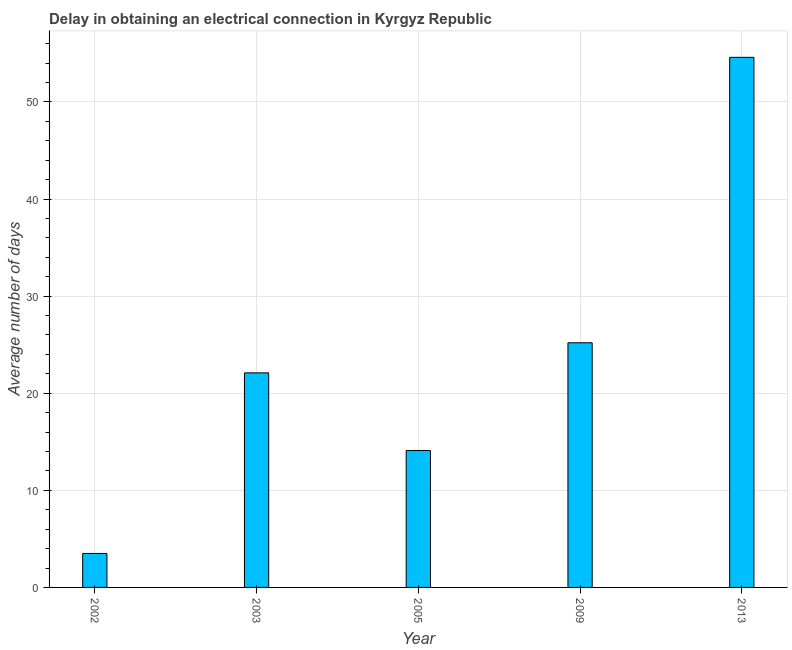What is the title of the graph?
Provide a short and direct response. Delay in obtaining an electrical connection in Kyrgyz Republic. What is the label or title of the Y-axis?
Give a very brief answer. Average number of days. What is the dalay in electrical connection in 2005?
Provide a short and direct response. 14.1. Across all years, what is the maximum dalay in electrical connection?
Provide a short and direct response. 54.6. Across all years, what is the minimum dalay in electrical connection?
Give a very brief answer. 3.5. In which year was the dalay in electrical connection maximum?
Your answer should be compact. 2013. What is the sum of the dalay in electrical connection?
Offer a terse response. 119.5. What is the difference between the dalay in electrical connection in 2002 and 2003?
Keep it short and to the point. -18.6. What is the average dalay in electrical connection per year?
Provide a succinct answer. 23.9. What is the median dalay in electrical connection?
Your answer should be compact. 22.1. In how many years, is the dalay in electrical connection greater than 54 days?
Keep it short and to the point. 1. What is the ratio of the dalay in electrical connection in 2009 to that in 2013?
Your answer should be compact. 0.46. Is the dalay in electrical connection in 2003 less than that in 2005?
Make the answer very short. No. Is the difference between the dalay in electrical connection in 2002 and 2009 greater than the difference between any two years?
Provide a succinct answer. No. What is the difference between the highest and the second highest dalay in electrical connection?
Your response must be concise. 29.4. What is the difference between the highest and the lowest dalay in electrical connection?
Your response must be concise. 51.1. Are all the bars in the graph horizontal?
Give a very brief answer. No. What is the difference between two consecutive major ticks on the Y-axis?
Provide a short and direct response. 10. Are the values on the major ticks of Y-axis written in scientific E-notation?
Make the answer very short. No. What is the Average number of days of 2002?
Ensure brevity in your answer.  3.5. What is the Average number of days in 2003?
Make the answer very short. 22.1. What is the Average number of days of 2009?
Your answer should be very brief. 25.2. What is the Average number of days in 2013?
Provide a succinct answer. 54.6. What is the difference between the Average number of days in 2002 and 2003?
Ensure brevity in your answer.  -18.6. What is the difference between the Average number of days in 2002 and 2009?
Provide a succinct answer. -21.7. What is the difference between the Average number of days in 2002 and 2013?
Your answer should be compact. -51.1. What is the difference between the Average number of days in 2003 and 2005?
Your answer should be compact. 8. What is the difference between the Average number of days in 2003 and 2009?
Give a very brief answer. -3.1. What is the difference between the Average number of days in 2003 and 2013?
Your answer should be compact. -32.5. What is the difference between the Average number of days in 2005 and 2013?
Offer a terse response. -40.5. What is the difference between the Average number of days in 2009 and 2013?
Provide a succinct answer. -29.4. What is the ratio of the Average number of days in 2002 to that in 2003?
Ensure brevity in your answer.  0.16. What is the ratio of the Average number of days in 2002 to that in 2005?
Your answer should be compact. 0.25. What is the ratio of the Average number of days in 2002 to that in 2009?
Keep it short and to the point. 0.14. What is the ratio of the Average number of days in 2002 to that in 2013?
Keep it short and to the point. 0.06. What is the ratio of the Average number of days in 2003 to that in 2005?
Offer a very short reply. 1.57. What is the ratio of the Average number of days in 2003 to that in 2009?
Make the answer very short. 0.88. What is the ratio of the Average number of days in 2003 to that in 2013?
Provide a succinct answer. 0.41. What is the ratio of the Average number of days in 2005 to that in 2009?
Your response must be concise. 0.56. What is the ratio of the Average number of days in 2005 to that in 2013?
Give a very brief answer. 0.26. What is the ratio of the Average number of days in 2009 to that in 2013?
Provide a succinct answer. 0.46. 